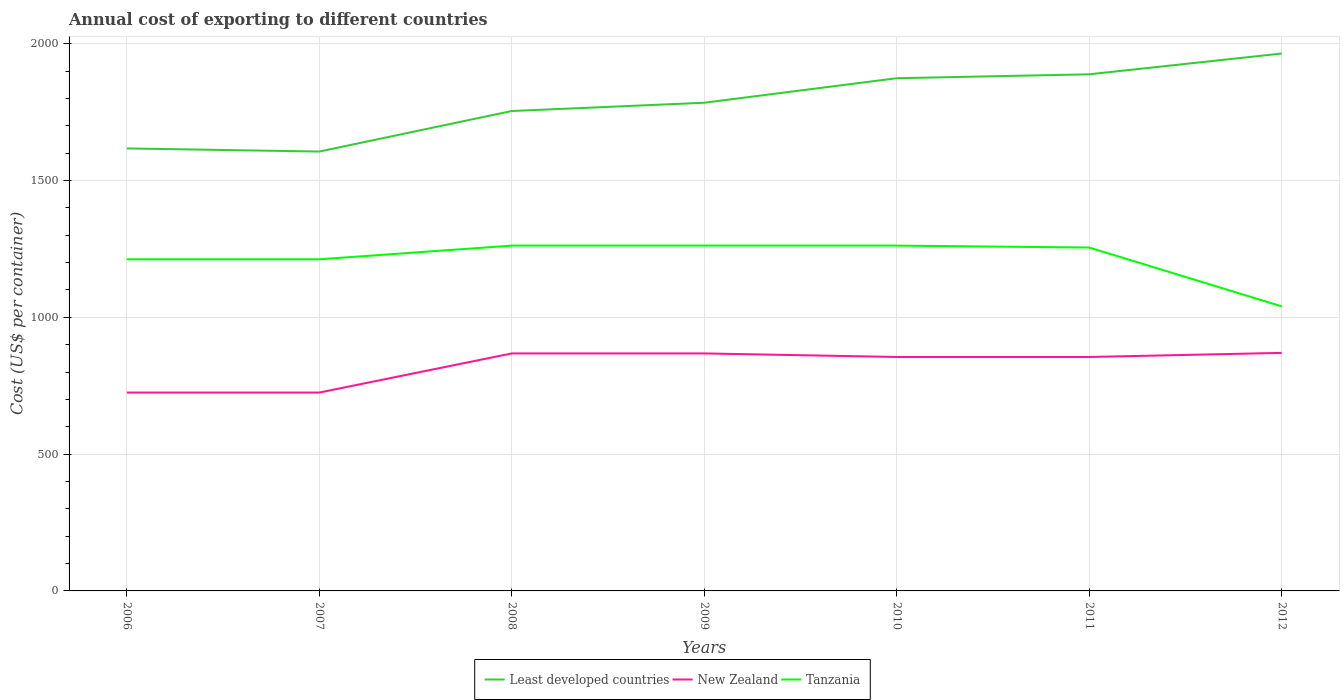How many different coloured lines are there?
Ensure brevity in your answer.  3. Is the number of lines equal to the number of legend labels?
Keep it short and to the point. Yes. Across all years, what is the maximum total annual cost of exporting in Tanzania?
Your answer should be very brief. 1040. In which year was the total annual cost of exporting in Least developed countries maximum?
Ensure brevity in your answer.  2007. What is the total total annual cost of exporting in Least developed countries in the graph?
Keep it short and to the point. -358.25. What is the difference between the highest and the second highest total annual cost of exporting in Least developed countries?
Make the answer very short. 358.25. Is the total annual cost of exporting in Least developed countries strictly greater than the total annual cost of exporting in Tanzania over the years?
Offer a terse response. No. How many years are there in the graph?
Give a very brief answer. 7. Does the graph contain grids?
Give a very brief answer. Yes. Where does the legend appear in the graph?
Keep it short and to the point. Bottom center. How are the legend labels stacked?
Provide a short and direct response. Horizontal. What is the title of the graph?
Make the answer very short. Annual cost of exporting to different countries. Does "Pakistan" appear as one of the legend labels in the graph?
Provide a short and direct response. No. What is the label or title of the X-axis?
Provide a short and direct response. Years. What is the label or title of the Y-axis?
Give a very brief answer. Cost (US$ per container). What is the Cost (US$ per container) of Least developed countries in 2006?
Make the answer very short. 1617.23. What is the Cost (US$ per container) of New Zealand in 2006?
Make the answer very short. 725. What is the Cost (US$ per container) in Tanzania in 2006?
Your answer should be compact. 1212. What is the Cost (US$ per container) in Least developed countries in 2007?
Ensure brevity in your answer.  1605.8. What is the Cost (US$ per container) in New Zealand in 2007?
Give a very brief answer. 725. What is the Cost (US$ per container) in Tanzania in 2007?
Provide a short and direct response. 1212. What is the Cost (US$ per container) of Least developed countries in 2008?
Make the answer very short. 1753.95. What is the Cost (US$ per container) in New Zealand in 2008?
Keep it short and to the point. 868. What is the Cost (US$ per container) of Tanzania in 2008?
Make the answer very short. 1262. What is the Cost (US$ per container) in Least developed countries in 2009?
Your answer should be compact. 1784.2. What is the Cost (US$ per container) of New Zealand in 2009?
Offer a very short reply. 868. What is the Cost (US$ per container) in Tanzania in 2009?
Make the answer very short. 1262. What is the Cost (US$ per container) of Least developed countries in 2010?
Your response must be concise. 1873.82. What is the Cost (US$ per container) of New Zealand in 2010?
Your answer should be very brief. 855. What is the Cost (US$ per container) of Tanzania in 2010?
Your answer should be very brief. 1262. What is the Cost (US$ per container) of Least developed countries in 2011?
Provide a short and direct response. 1888.14. What is the Cost (US$ per container) of New Zealand in 2011?
Make the answer very short. 855. What is the Cost (US$ per container) in Tanzania in 2011?
Make the answer very short. 1255. What is the Cost (US$ per container) in Least developed countries in 2012?
Provide a succinct answer. 1964.04. What is the Cost (US$ per container) of New Zealand in 2012?
Your answer should be compact. 870. What is the Cost (US$ per container) in Tanzania in 2012?
Provide a succinct answer. 1040. Across all years, what is the maximum Cost (US$ per container) in Least developed countries?
Make the answer very short. 1964.04. Across all years, what is the maximum Cost (US$ per container) in New Zealand?
Make the answer very short. 870. Across all years, what is the maximum Cost (US$ per container) in Tanzania?
Ensure brevity in your answer.  1262. Across all years, what is the minimum Cost (US$ per container) of Least developed countries?
Your answer should be compact. 1605.8. Across all years, what is the minimum Cost (US$ per container) of New Zealand?
Ensure brevity in your answer.  725. Across all years, what is the minimum Cost (US$ per container) of Tanzania?
Your answer should be very brief. 1040. What is the total Cost (US$ per container) in Least developed countries in the graph?
Offer a very short reply. 1.25e+04. What is the total Cost (US$ per container) of New Zealand in the graph?
Your answer should be very brief. 5766. What is the total Cost (US$ per container) of Tanzania in the graph?
Your answer should be very brief. 8505. What is the difference between the Cost (US$ per container) in Least developed countries in 2006 and that in 2007?
Your response must be concise. 11.43. What is the difference between the Cost (US$ per container) in New Zealand in 2006 and that in 2007?
Give a very brief answer. 0. What is the difference between the Cost (US$ per container) of Tanzania in 2006 and that in 2007?
Your answer should be compact. 0. What is the difference between the Cost (US$ per container) in Least developed countries in 2006 and that in 2008?
Your answer should be very brief. -136.73. What is the difference between the Cost (US$ per container) in New Zealand in 2006 and that in 2008?
Keep it short and to the point. -143. What is the difference between the Cost (US$ per container) in Least developed countries in 2006 and that in 2009?
Provide a succinct answer. -166.98. What is the difference between the Cost (US$ per container) of New Zealand in 2006 and that in 2009?
Provide a succinct answer. -143. What is the difference between the Cost (US$ per container) of Least developed countries in 2006 and that in 2010?
Your response must be concise. -256.59. What is the difference between the Cost (US$ per container) in New Zealand in 2006 and that in 2010?
Provide a short and direct response. -130. What is the difference between the Cost (US$ per container) of Least developed countries in 2006 and that in 2011?
Give a very brief answer. -270.91. What is the difference between the Cost (US$ per container) of New Zealand in 2006 and that in 2011?
Your answer should be very brief. -130. What is the difference between the Cost (US$ per container) in Tanzania in 2006 and that in 2011?
Provide a short and direct response. -43. What is the difference between the Cost (US$ per container) in Least developed countries in 2006 and that in 2012?
Provide a short and direct response. -346.82. What is the difference between the Cost (US$ per container) of New Zealand in 2006 and that in 2012?
Your response must be concise. -145. What is the difference between the Cost (US$ per container) of Tanzania in 2006 and that in 2012?
Provide a short and direct response. 172. What is the difference between the Cost (US$ per container) in Least developed countries in 2007 and that in 2008?
Give a very brief answer. -148.16. What is the difference between the Cost (US$ per container) in New Zealand in 2007 and that in 2008?
Your response must be concise. -143. What is the difference between the Cost (US$ per container) of Tanzania in 2007 and that in 2008?
Offer a terse response. -50. What is the difference between the Cost (US$ per container) in Least developed countries in 2007 and that in 2009?
Offer a very short reply. -178.41. What is the difference between the Cost (US$ per container) of New Zealand in 2007 and that in 2009?
Your answer should be compact. -143. What is the difference between the Cost (US$ per container) of Least developed countries in 2007 and that in 2010?
Provide a succinct answer. -268.02. What is the difference between the Cost (US$ per container) of New Zealand in 2007 and that in 2010?
Offer a terse response. -130. What is the difference between the Cost (US$ per container) of Least developed countries in 2007 and that in 2011?
Your response must be concise. -282.34. What is the difference between the Cost (US$ per container) of New Zealand in 2007 and that in 2011?
Make the answer very short. -130. What is the difference between the Cost (US$ per container) of Tanzania in 2007 and that in 2011?
Offer a very short reply. -43. What is the difference between the Cost (US$ per container) of Least developed countries in 2007 and that in 2012?
Keep it short and to the point. -358.25. What is the difference between the Cost (US$ per container) of New Zealand in 2007 and that in 2012?
Provide a short and direct response. -145. What is the difference between the Cost (US$ per container) of Tanzania in 2007 and that in 2012?
Ensure brevity in your answer.  172. What is the difference between the Cost (US$ per container) of Least developed countries in 2008 and that in 2009?
Keep it short and to the point. -30.25. What is the difference between the Cost (US$ per container) of New Zealand in 2008 and that in 2009?
Offer a very short reply. 0. What is the difference between the Cost (US$ per container) in Tanzania in 2008 and that in 2009?
Offer a terse response. 0. What is the difference between the Cost (US$ per container) in Least developed countries in 2008 and that in 2010?
Make the answer very short. -119.86. What is the difference between the Cost (US$ per container) in Least developed countries in 2008 and that in 2011?
Offer a terse response. -134.18. What is the difference between the Cost (US$ per container) of Tanzania in 2008 and that in 2011?
Provide a succinct answer. 7. What is the difference between the Cost (US$ per container) of Least developed countries in 2008 and that in 2012?
Keep it short and to the point. -210.09. What is the difference between the Cost (US$ per container) of Tanzania in 2008 and that in 2012?
Your answer should be very brief. 222. What is the difference between the Cost (US$ per container) of Least developed countries in 2009 and that in 2010?
Your answer should be very brief. -89.61. What is the difference between the Cost (US$ per container) of New Zealand in 2009 and that in 2010?
Ensure brevity in your answer.  13. What is the difference between the Cost (US$ per container) of Tanzania in 2009 and that in 2010?
Provide a succinct answer. 0. What is the difference between the Cost (US$ per container) of Least developed countries in 2009 and that in 2011?
Make the answer very short. -103.93. What is the difference between the Cost (US$ per container) of Least developed countries in 2009 and that in 2012?
Provide a succinct answer. -179.84. What is the difference between the Cost (US$ per container) in New Zealand in 2009 and that in 2012?
Keep it short and to the point. -2. What is the difference between the Cost (US$ per container) in Tanzania in 2009 and that in 2012?
Offer a very short reply. 222. What is the difference between the Cost (US$ per container) in Least developed countries in 2010 and that in 2011?
Make the answer very short. -14.32. What is the difference between the Cost (US$ per container) of New Zealand in 2010 and that in 2011?
Provide a succinct answer. 0. What is the difference between the Cost (US$ per container) in Tanzania in 2010 and that in 2011?
Provide a succinct answer. 7. What is the difference between the Cost (US$ per container) of Least developed countries in 2010 and that in 2012?
Provide a short and direct response. -90.23. What is the difference between the Cost (US$ per container) of New Zealand in 2010 and that in 2012?
Your response must be concise. -15. What is the difference between the Cost (US$ per container) of Tanzania in 2010 and that in 2012?
Offer a very short reply. 222. What is the difference between the Cost (US$ per container) of Least developed countries in 2011 and that in 2012?
Your response must be concise. -75.91. What is the difference between the Cost (US$ per container) in New Zealand in 2011 and that in 2012?
Offer a very short reply. -15. What is the difference between the Cost (US$ per container) in Tanzania in 2011 and that in 2012?
Provide a short and direct response. 215. What is the difference between the Cost (US$ per container) of Least developed countries in 2006 and the Cost (US$ per container) of New Zealand in 2007?
Keep it short and to the point. 892.23. What is the difference between the Cost (US$ per container) of Least developed countries in 2006 and the Cost (US$ per container) of Tanzania in 2007?
Your response must be concise. 405.23. What is the difference between the Cost (US$ per container) of New Zealand in 2006 and the Cost (US$ per container) of Tanzania in 2007?
Give a very brief answer. -487. What is the difference between the Cost (US$ per container) of Least developed countries in 2006 and the Cost (US$ per container) of New Zealand in 2008?
Ensure brevity in your answer.  749.23. What is the difference between the Cost (US$ per container) of Least developed countries in 2006 and the Cost (US$ per container) of Tanzania in 2008?
Offer a terse response. 355.23. What is the difference between the Cost (US$ per container) of New Zealand in 2006 and the Cost (US$ per container) of Tanzania in 2008?
Provide a short and direct response. -537. What is the difference between the Cost (US$ per container) in Least developed countries in 2006 and the Cost (US$ per container) in New Zealand in 2009?
Give a very brief answer. 749.23. What is the difference between the Cost (US$ per container) of Least developed countries in 2006 and the Cost (US$ per container) of Tanzania in 2009?
Your answer should be compact. 355.23. What is the difference between the Cost (US$ per container) of New Zealand in 2006 and the Cost (US$ per container) of Tanzania in 2009?
Make the answer very short. -537. What is the difference between the Cost (US$ per container) of Least developed countries in 2006 and the Cost (US$ per container) of New Zealand in 2010?
Provide a succinct answer. 762.23. What is the difference between the Cost (US$ per container) in Least developed countries in 2006 and the Cost (US$ per container) in Tanzania in 2010?
Your response must be concise. 355.23. What is the difference between the Cost (US$ per container) of New Zealand in 2006 and the Cost (US$ per container) of Tanzania in 2010?
Your response must be concise. -537. What is the difference between the Cost (US$ per container) in Least developed countries in 2006 and the Cost (US$ per container) in New Zealand in 2011?
Offer a terse response. 762.23. What is the difference between the Cost (US$ per container) of Least developed countries in 2006 and the Cost (US$ per container) of Tanzania in 2011?
Ensure brevity in your answer.  362.23. What is the difference between the Cost (US$ per container) of New Zealand in 2006 and the Cost (US$ per container) of Tanzania in 2011?
Provide a succinct answer. -530. What is the difference between the Cost (US$ per container) of Least developed countries in 2006 and the Cost (US$ per container) of New Zealand in 2012?
Make the answer very short. 747.23. What is the difference between the Cost (US$ per container) in Least developed countries in 2006 and the Cost (US$ per container) in Tanzania in 2012?
Provide a short and direct response. 577.23. What is the difference between the Cost (US$ per container) of New Zealand in 2006 and the Cost (US$ per container) of Tanzania in 2012?
Your answer should be compact. -315. What is the difference between the Cost (US$ per container) in Least developed countries in 2007 and the Cost (US$ per container) in New Zealand in 2008?
Ensure brevity in your answer.  737.8. What is the difference between the Cost (US$ per container) in Least developed countries in 2007 and the Cost (US$ per container) in Tanzania in 2008?
Ensure brevity in your answer.  343.8. What is the difference between the Cost (US$ per container) of New Zealand in 2007 and the Cost (US$ per container) of Tanzania in 2008?
Make the answer very short. -537. What is the difference between the Cost (US$ per container) in Least developed countries in 2007 and the Cost (US$ per container) in New Zealand in 2009?
Your answer should be compact. 737.8. What is the difference between the Cost (US$ per container) of Least developed countries in 2007 and the Cost (US$ per container) of Tanzania in 2009?
Make the answer very short. 343.8. What is the difference between the Cost (US$ per container) of New Zealand in 2007 and the Cost (US$ per container) of Tanzania in 2009?
Give a very brief answer. -537. What is the difference between the Cost (US$ per container) of Least developed countries in 2007 and the Cost (US$ per container) of New Zealand in 2010?
Provide a succinct answer. 750.8. What is the difference between the Cost (US$ per container) of Least developed countries in 2007 and the Cost (US$ per container) of Tanzania in 2010?
Provide a succinct answer. 343.8. What is the difference between the Cost (US$ per container) of New Zealand in 2007 and the Cost (US$ per container) of Tanzania in 2010?
Keep it short and to the point. -537. What is the difference between the Cost (US$ per container) in Least developed countries in 2007 and the Cost (US$ per container) in New Zealand in 2011?
Your answer should be very brief. 750.8. What is the difference between the Cost (US$ per container) of Least developed countries in 2007 and the Cost (US$ per container) of Tanzania in 2011?
Offer a terse response. 350.8. What is the difference between the Cost (US$ per container) in New Zealand in 2007 and the Cost (US$ per container) in Tanzania in 2011?
Make the answer very short. -530. What is the difference between the Cost (US$ per container) in Least developed countries in 2007 and the Cost (US$ per container) in New Zealand in 2012?
Ensure brevity in your answer.  735.8. What is the difference between the Cost (US$ per container) in Least developed countries in 2007 and the Cost (US$ per container) in Tanzania in 2012?
Ensure brevity in your answer.  565.8. What is the difference between the Cost (US$ per container) in New Zealand in 2007 and the Cost (US$ per container) in Tanzania in 2012?
Make the answer very short. -315. What is the difference between the Cost (US$ per container) of Least developed countries in 2008 and the Cost (US$ per container) of New Zealand in 2009?
Ensure brevity in your answer.  885.95. What is the difference between the Cost (US$ per container) in Least developed countries in 2008 and the Cost (US$ per container) in Tanzania in 2009?
Your answer should be very brief. 491.95. What is the difference between the Cost (US$ per container) in New Zealand in 2008 and the Cost (US$ per container) in Tanzania in 2009?
Ensure brevity in your answer.  -394. What is the difference between the Cost (US$ per container) in Least developed countries in 2008 and the Cost (US$ per container) in New Zealand in 2010?
Provide a short and direct response. 898.95. What is the difference between the Cost (US$ per container) of Least developed countries in 2008 and the Cost (US$ per container) of Tanzania in 2010?
Make the answer very short. 491.95. What is the difference between the Cost (US$ per container) of New Zealand in 2008 and the Cost (US$ per container) of Tanzania in 2010?
Your answer should be compact. -394. What is the difference between the Cost (US$ per container) of Least developed countries in 2008 and the Cost (US$ per container) of New Zealand in 2011?
Provide a short and direct response. 898.95. What is the difference between the Cost (US$ per container) of Least developed countries in 2008 and the Cost (US$ per container) of Tanzania in 2011?
Your answer should be very brief. 498.95. What is the difference between the Cost (US$ per container) of New Zealand in 2008 and the Cost (US$ per container) of Tanzania in 2011?
Keep it short and to the point. -387. What is the difference between the Cost (US$ per container) of Least developed countries in 2008 and the Cost (US$ per container) of New Zealand in 2012?
Provide a succinct answer. 883.95. What is the difference between the Cost (US$ per container) in Least developed countries in 2008 and the Cost (US$ per container) in Tanzania in 2012?
Ensure brevity in your answer.  713.95. What is the difference between the Cost (US$ per container) in New Zealand in 2008 and the Cost (US$ per container) in Tanzania in 2012?
Ensure brevity in your answer.  -172. What is the difference between the Cost (US$ per container) of Least developed countries in 2009 and the Cost (US$ per container) of New Zealand in 2010?
Your answer should be very brief. 929.2. What is the difference between the Cost (US$ per container) in Least developed countries in 2009 and the Cost (US$ per container) in Tanzania in 2010?
Keep it short and to the point. 522.2. What is the difference between the Cost (US$ per container) of New Zealand in 2009 and the Cost (US$ per container) of Tanzania in 2010?
Offer a terse response. -394. What is the difference between the Cost (US$ per container) of Least developed countries in 2009 and the Cost (US$ per container) of New Zealand in 2011?
Provide a succinct answer. 929.2. What is the difference between the Cost (US$ per container) in Least developed countries in 2009 and the Cost (US$ per container) in Tanzania in 2011?
Make the answer very short. 529.2. What is the difference between the Cost (US$ per container) in New Zealand in 2009 and the Cost (US$ per container) in Tanzania in 2011?
Offer a very short reply. -387. What is the difference between the Cost (US$ per container) of Least developed countries in 2009 and the Cost (US$ per container) of New Zealand in 2012?
Ensure brevity in your answer.  914.2. What is the difference between the Cost (US$ per container) in Least developed countries in 2009 and the Cost (US$ per container) in Tanzania in 2012?
Your answer should be very brief. 744.2. What is the difference between the Cost (US$ per container) of New Zealand in 2009 and the Cost (US$ per container) of Tanzania in 2012?
Provide a short and direct response. -172. What is the difference between the Cost (US$ per container) of Least developed countries in 2010 and the Cost (US$ per container) of New Zealand in 2011?
Give a very brief answer. 1018.82. What is the difference between the Cost (US$ per container) in Least developed countries in 2010 and the Cost (US$ per container) in Tanzania in 2011?
Give a very brief answer. 618.82. What is the difference between the Cost (US$ per container) in New Zealand in 2010 and the Cost (US$ per container) in Tanzania in 2011?
Provide a succinct answer. -400. What is the difference between the Cost (US$ per container) in Least developed countries in 2010 and the Cost (US$ per container) in New Zealand in 2012?
Make the answer very short. 1003.82. What is the difference between the Cost (US$ per container) in Least developed countries in 2010 and the Cost (US$ per container) in Tanzania in 2012?
Make the answer very short. 833.82. What is the difference between the Cost (US$ per container) of New Zealand in 2010 and the Cost (US$ per container) of Tanzania in 2012?
Ensure brevity in your answer.  -185. What is the difference between the Cost (US$ per container) of Least developed countries in 2011 and the Cost (US$ per container) of New Zealand in 2012?
Make the answer very short. 1018.14. What is the difference between the Cost (US$ per container) in Least developed countries in 2011 and the Cost (US$ per container) in Tanzania in 2012?
Your answer should be very brief. 848.14. What is the difference between the Cost (US$ per container) of New Zealand in 2011 and the Cost (US$ per container) of Tanzania in 2012?
Provide a short and direct response. -185. What is the average Cost (US$ per container) of Least developed countries per year?
Ensure brevity in your answer.  1783.88. What is the average Cost (US$ per container) in New Zealand per year?
Provide a short and direct response. 823.71. What is the average Cost (US$ per container) of Tanzania per year?
Provide a succinct answer. 1215. In the year 2006, what is the difference between the Cost (US$ per container) in Least developed countries and Cost (US$ per container) in New Zealand?
Give a very brief answer. 892.23. In the year 2006, what is the difference between the Cost (US$ per container) of Least developed countries and Cost (US$ per container) of Tanzania?
Offer a terse response. 405.23. In the year 2006, what is the difference between the Cost (US$ per container) of New Zealand and Cost (US$ per container) of Tanzania?
Provide a short and direct response. -487. In the year 2007, what is the difference between the Cost (US$ per container) in Least developed countries and Cost (US$ per container) in New Zealand?
Make the answer very short. 880.8. In the year 2007, what is the difference between the Cost (US$ per container) of Least developed countries and Cost (US$ per container) of Tanzania?
Your response must be concise. 393.8. In the year 2007, what is the difference between the Cost (US$ per container) in New Zealand and Cost (US$ per container) in Tanzania?
Make the answer very short. -487. In the year 2008, what is the difference between the Cost (US$ per container) in Least developed countries and Cost (US$ per container) in New Zealand?
Provide a short and direct response. 885.95. In the year 2008, what is the difference between the Cost (US$ per container) of Least developed countries and Cost (US$ per container) of Tanzania?
Provide a short and direct response. 491.95. In the year 2008, what is the difference between the Cost (US$ per container) in New Zealand and Cost (US$ per container) in Tanzania?
Offer a terse response. -394. In the year 2009, what is the difference between the Cost (US$ per container) of Least developed countries and Cost (US$ per container) of New Zealand?
Your answer should be very brief. 916.2. In the year 2009, what is the difference between the Cost (US$ per container) of Least developed countries and Cost (US$ per container) of Tanzania?
Your answer should be very brief. 522.2. In the year 2009, what is the difference between the Cost (US$ per container) in New Zealand and Cost (US$ per container) in Tanzania?
Offer a terse response. -394. In the year 2010, what is the difference between the Cost (US$ per container) of Least developed countries and Cost (US$ per container) of New Zealand?
Your answer should be very brief. 1018.82. In the year 2010, what is the difference between the Cost (US$ per container) of Least developed countries and Cost (US$ per container) of Tanzania?
Provide a short and direct response. 611.82. In the year 2010, what is the difference between the Cost (US$ per container) of New Zealand and Cost (US$ per container) of Tanzania?
Offer a terse response. -407. In the year 2011, what is the difference between the Cost (US$ per container) in Least developed countries and Cost (US$ per container) in New Zealand?
Offer a very short reply. 1033.14. In the year 2011, what is the difference between the Cost (US$ per container) of Least developed countries and Cost (US$ per container) of Tanzania?
Offer a very short reply. 633.14. In the year 2011, what is the difference between the Cost (US$ per container) of New Zealand and Cost (US$ per container) of Tanzania?
Offer a terse response. -400. In the year 2012, what is the difference between the Cost (US$ per container) of Least developed countries and Cost (US$ per container) of New Zealand?
Your answer should be compact. 1094.04. In the year 2012, what is the difference between the Cost (US$ per container) of Least developed countries and Cost (US$ per container) of Tanzania?
Ensure brevity in your answer.  924.04. In the year 2012, what is the difference between the Cost (US$ per container) in New Zealand and Cost (US$ per container) in Tanzania?
Ensure brevity in your answer.  -170. What is the ratio of the Cost (US$ per container) of Least developed countries in 2006 to that in 2007?
Keep it short and to the point. 1.01. What is the ratio of the Cost (US$ per container) in Least developed countries in 2006 to that in 2008?
Keep it short and to the point. 0.92. What is the ratio of the Cost (US$ per container) in New Zealand in 2006 to that in 2008?
Give a very brief answer. 0.84. What is the ratio of the Cost (US$ per container) of Tanzania in 2006 to that in 2008?
Provide a succinct answer. 0.96. What is the ratio of the Cost (US$ per container) of Least developed countries in 2006 to that in 2009?
Offer a terse response. 0.91. What is the ratio of the Cost (US$ per container) in New Zealand in 2006 to that in 2009?
Provide a short and direct response. 0.84. What is the ratio of the Cost (US$ per container) in Tanzania in 2006 to that in 2009?
Offer a terse response. 0.96. What is the ratio of the Cost (US$ per container) in Least developed countries in 2006 to that in 2010?
Give a very brief answer. 0.86. What is the ratio of the Cost (US$ per container) in New Zealand in 2006 to that in 2010?
Your answer should be compact. 0.85. What is the ratio of the Cost (US$ per container) in Tanzania in 2006 to that in 2010?
Make the answer very short. 0.96. What is the ratio of the Cost (US$ per container) in Least developed countries in 2006 to that in 2011?
Keep it short and to the point. 0.86. What is the ratio of the Cost (US$ per container) in New Zealand in 2006 to that in 2011?
Offer a very short reply. 0.85. What is the ratio of the Cost (US$ per container) in Tanzania in 2006 to that in 2011?
Ensure brevity in your answer.  0.97. What is the ratio of the Cost (US$ per container) in Least developed countries in 2006 to that in 2012?
Keep it short and to the point. 0.82. What is the ratio of the Cost (US$ per container) of New Zealand in 2006 to that in 2012?
Your answer should be very brief. 0.83. What is the ratio of the Cost (US$ per container) in Tanzania in 2006 to that in 2012?
Your answer should be very brief. 1.17. What is the ratio of the Cost (US$ per container) of Least developed countries in 2007 to that in 2008?
Your answer should be very brief. 0.92. What is the ratio of the Cost (US$ per container) in New Zealand in 2007 to that in 2008?
Keep it short and to the point. 0.84. What is the ratio of the Cost (US$ per container) of Tanzania in 2007 to that in 2008?
Ensure brevity in your answer.  0.96. What is the ratio of the Cost (US$ per container) in New Zealand in 2007 to that in 2009?
Your response must be concise. 0.84. What is the ratio of the Cost (US$ per container) in Tanzania in 2007 to that in 2009?
Offer a very short reply. 0.96. What is the ratio of the Cost (US$ per container) in Least developed countries in 2007 to that in 2010?
Provide a short and direct response. 0.86. What is the ratio of the Cost (US$ per container) in New Zealand in 2007 to that in 2010?
Provide a succinct answer. 0.85. What is the ratio of the Cost (US$ per container) in Tanzania in 2007 to that in 2010?
Make the answer very short. 0.96. What is the ratio of the Cost (US$ per container) of Least developed countries in 2007 to that in 2011?
Give a very brief answer. 0.85. What is the ratio of the Cost (US$ per container) of New Zealand in 2007 to that in 2011?
Offer a very short reply. 0.85. What is the ratio of the Cost (US$ per container) in Tanzania in 2007 to that in 2011?
Your answer should be very brief. 0.97. What is the ratio of the Cost (US$ per container) in Least developed countries in 2007 to that in 2012?
Provide a short and direct response. 0.82. What is the ratio of the Cost (US$ per container) in Tanzania in 2007 to that in 2012?
Your answer should be very brief. 1.17. What is the ratio of the Cost (US$ per container) of Least developed countries in 2008 to that in 2010?
Your response must be concise. 0.94. What is the ratio of the Cost (US$ per container) of New Zealand in 2008 to that in 2010?
Offer a terse response. 1.02. What is the ratio of the Cost (US$ per container) of Tanzania in 2008 to that in 2010?
Offer a terse response. 1. What is the ratio of the Cost (US$ per container) in Least developed countries in 2008 to that in 2011?
Keep it short and to the point. 0.93. What is the ratio of the Cost (US$ per container) in New Zealand in 2008 to that in 2011?
Your response must be concise. 1.02. What is the ratio of the Cost (US$ per container) of Tanzania in 2008 to that in 2011?
Your answer should be compact. 1.01. What is the ratio of the Cost (US$ per container) in Least developed countries in 2008 to that in 2012?
Your answer should be very brief. 0.89. What is the ratio of the Cost (US$ per container) in Tanzania in 2008 to that in 2012?
Your answer should be compact. 1.21. What is the ratio of the Cost (US$ per container) of Least developed countries in 2009 to that in 2010?
Give a very brief answer. 0.95. What is the ratio of the Cost (US$ per container) in New Zealand in 2009 to that in 2010?
Your response must be concise. 1.02. What is the ratio of the Cost (US$ per container) of Least developed countries in 2009 to that in 2011?
Provide a succinct answer. 0.94. What is the ratio of the Cost (US$ per container) in New Zealand in 2009 to that in 2011?
Provide a short and direct response. 1.02. What is the ratio of the Cost (US$ per container) of Tanzania in 2009 to that in 2011?
Give a very brief answer. 1.01. What is the ratio of the Cost (US$ per container) of Least developed countries in 2009 to that in 2012?
Make the answer very short. 0.91. What is the ratio of the Cost (US$ per container) of New Zealand in 2009 to that in 2012?
Make the answer very short. 1. What is the ratio of the Cost (US$ per container) of Tanzania in 2009 to that in 2012?
Make the answer very short. 1.21. What is the ratio of the Cost (US$ per container) in New Zealand in 2010 to that in 2011?
Your response must be concise. 1. What is the ratio of the Cost (US$ per container) in Tanzania in 2010 to that in 2011?
Give a very brief answer. 1.01. What is the ratio of the Cost (US$ per container) of Least developed countries in 2010 to that in 2012?
Keep it short and to the point. 0.95. What is the ratio of the Cost (US$ per container) in New Zealand in 2010 to that in 2012?
Provide a succinct answer. 0.98. What is the ratio of the Cost (US$ per container) of Tanzania in 2010 to that in 2012?
Make the answer very short. 1.21. What is the ratio of the Cost (US$ per container) of Least developed countries in 2011 to that in 2012?
Your answer should be compact. 0.96. What is the ratio of the Cost (US$ per container) in New Zealand in 2011 to that in 2012?
Make the answer very short. 0.98. What is the ratio of the Cost (US$ per container) in Tanzania in 2011 to that in 2012?
Your answer should be compact. 1.21. What is the difference between the highest and the second highest Cost (US$ per container) in Least developed countries?
Your response must be concise. 75.91. What is the difference between the highest and the second highest Cost (US$ per container) of Tanzania?
Your answer should be compact. 0. What is the difference between the highest and the lowest Cost (US$ per container) of Least developed countries?
Offer a very short reply. 358.25. What is the difference between the highest and the lowest Cost (US$ per container) of New Zealand?
Offer a terse response. 145. What is the difference between the highest and the lowest Cost (US$ per container) in Tanzania?
Offer a terse response. 222. 